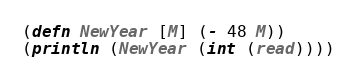<code> <loc_0><loc_0><loc_500><loc_500><_Clojure_>(defn NewYear [M] (- 48 M))
(println (NewYear (int (read))))</code> 